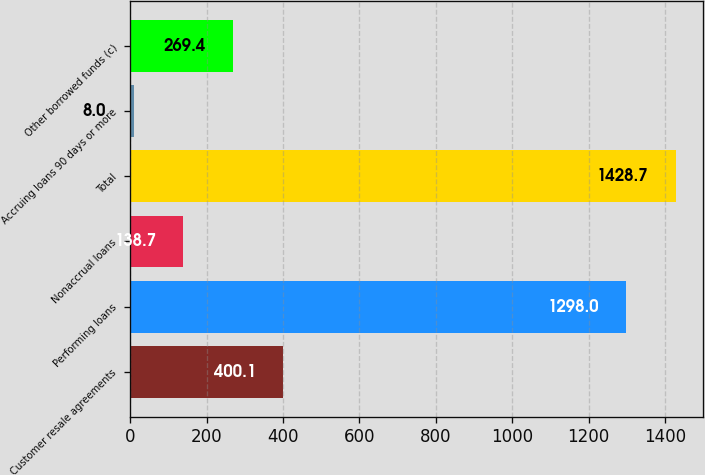Convert chart. <chart><loc_0><loc_0><loc_500><loc_500><bar_chart><fcel>Customer resale agreements<fcel>Performing loans<fcel>Nonaccrual loans<fcel>Total<fcel>Accruing loans 90 days or more<fcel>Other borrowed funds (c)<nl><fcel>400.1<fcel>1298<fcel>138.7<fcel>1428.7<fcel>8<fcel>269.4<nl></chart> 